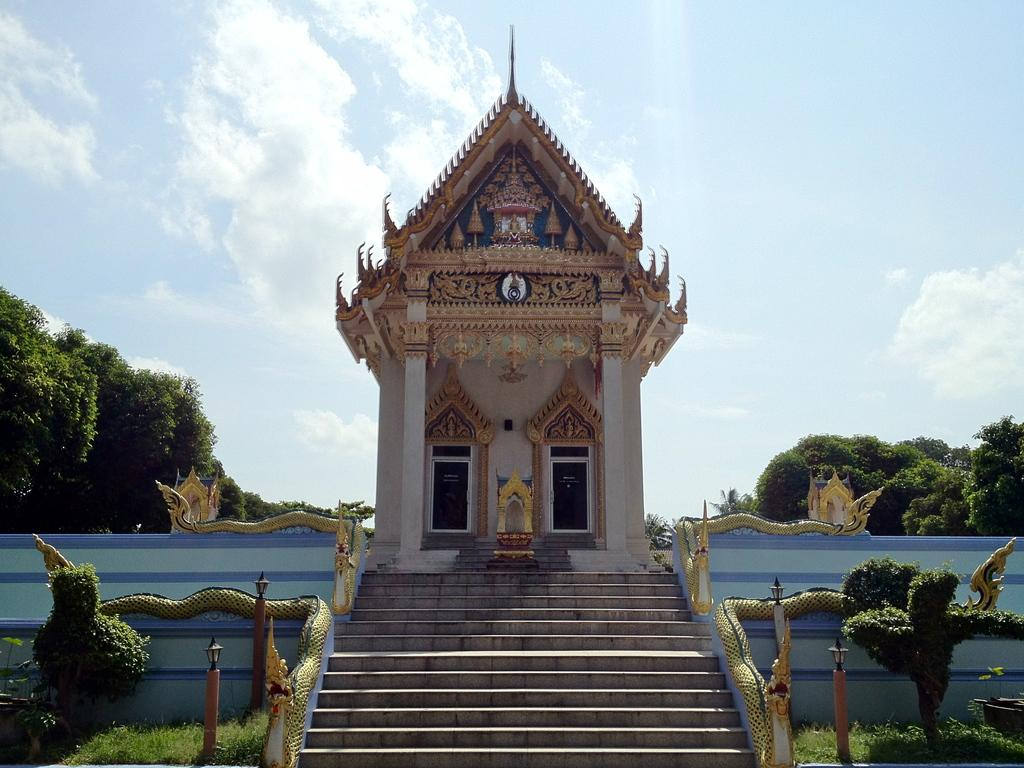What types of vegetation can be seen in the foreground of the picture? There are plants and grass in the foreground of the picture. What architectural feature is present in the foreground of the picture? There is a staircase in the foreground of the picture. What is happening in the foreground of the picture? There is a construction in the foreground of the picture. What can be seen in the background of the picture? There are trees in the background of the picture. How would you describe the weather in the image? The sky is sunny in the image. What type of linen is draped over the construction site in the image? There is no linen present in the image; it features plants, grass, a staircase, construction, trees, and a sunny sky. What art piece can be seen hanging on the trees in the background? There is no art piece visible in the image; it only shows plants, grass, a staircase, construction, trees, and a sunny sky. 